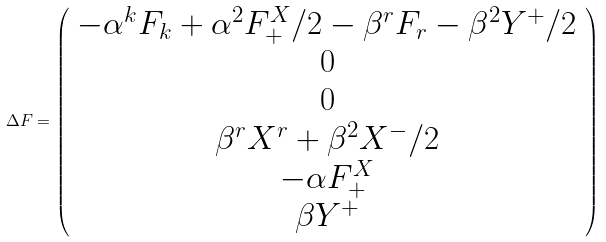Convert formula to latex. <formula><loc_0><loc_0><loc_500><loc_500>\Delta F = \left ( \begin{array} { c } - \alpha ^ { k } F _ { k } + \alpha ^ { 2 } F _ { + } ^ { X } / 2 - \beta ^ { r } F _ { r } - \beta ^ { 2 } Y ^ { + } / 2 \\ 0 \\ 0 \\ \beta ^ { r } X ^ { r } + \beta ^ { 2 } X ^ { - } / 2 \\ - \alpha F _ { + } ^ { X } \\ \beta Y ^ { + } \end{array} \right )</formula> 